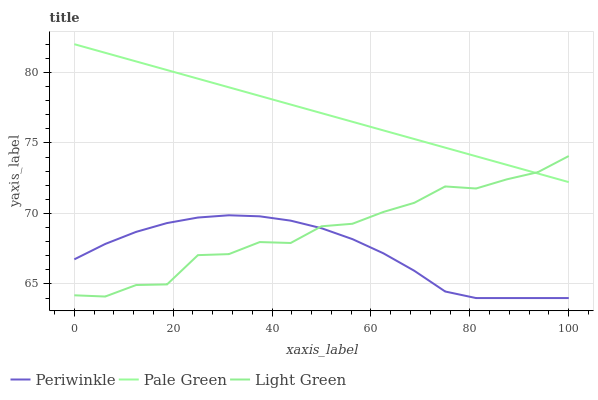Does Periwinkle have the minimum area under the curve?
Answer yes or no. Yes. Does Pale Green have the maximum area under the curve?
Answer yes or no. Yes. Does Light Green have the minimum area under the curve?
Answer yes or no. No. Does Light Green have the maximum area under the curve?
Answer yes or no. No. Is Pale Green the smoothest?
Answer yes or no. Yes. Is Light Green the roughest?
Answer yes or no. Yes. Is Periwinkle the smoothest?
Answer yes or no. No. Is Periwinkle the roughest?
Answer yes or no. No. Does Periwinkle have the lowest value?
Answer yes or no. Yes. Does Light Green have the lowest value?
Answer yes or no. No. Does Pale Green have the highest value?
Answer yes or no. Yes. Does Light Green have the highest value?
Answer yes or no. No. Is Periwinkle less than Pale Green?
Answer yes or no. Yes. Is Pale Green greater than Periwinkle?
Answer yes or no. Yes. Does Pale Green intersect Light Green?
Answer yes or no. Yes. Is Pale Green less than Light Green?
Answer yes or no. No. Is Pale Green greater than Light Green?
Answer yes or no. No. Does Periwinkle intersect Pale Green?
Answer yes or no. No. 